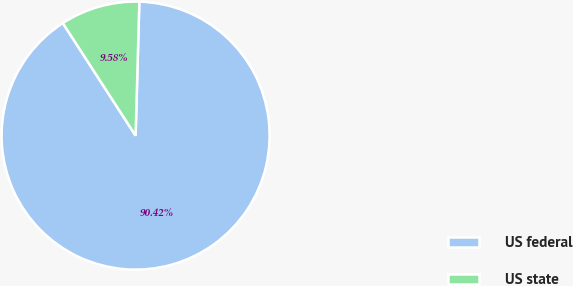Convert chart to OTSL. <chart><loc_0><loc_0><loc_500><loc_500><pie_chart><fcel>US federal<fcel>US state<nl><fcel>90.42%<fcel>9.58%<nl></chart> 